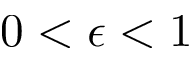Convert formula to latex. <formula><loc_0><loc_0><loc_500><loc_500>0 < \epsilon < 1</formula> 